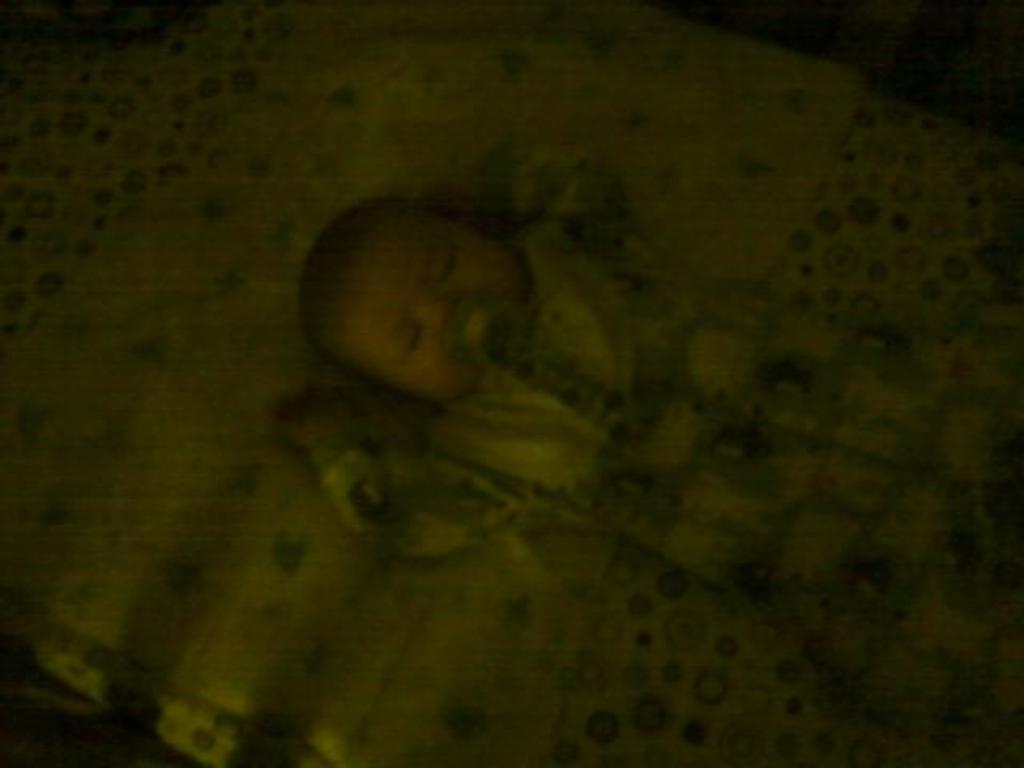Can you describe this image briefly? In this image I can see the dark picture. I can see the baby is sleeping on the bed. 